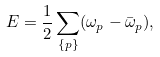<formula> <loc_0><loc_0><loc_500><loc_500>E = \frac { 1 } { 2 } \sum _ { \{ p \} } ( \omega _ { p } - \bar { \omega } _ { p } ) ,</formula> 